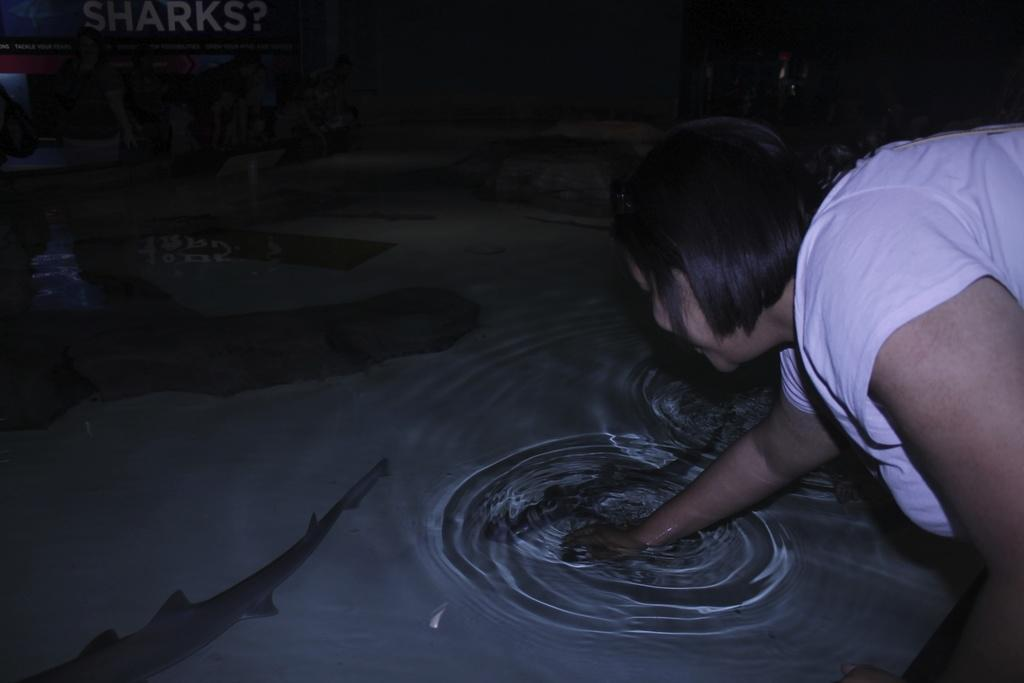What is in the water in the center of the image? There are sharks in the water in the center of the image. Can you describe what is on the right side of the image? There is a lady on the right side of the image. How many umbrellas are visible in the image? There are no umbrellas present in the image, and therefore no limit can be determined. 